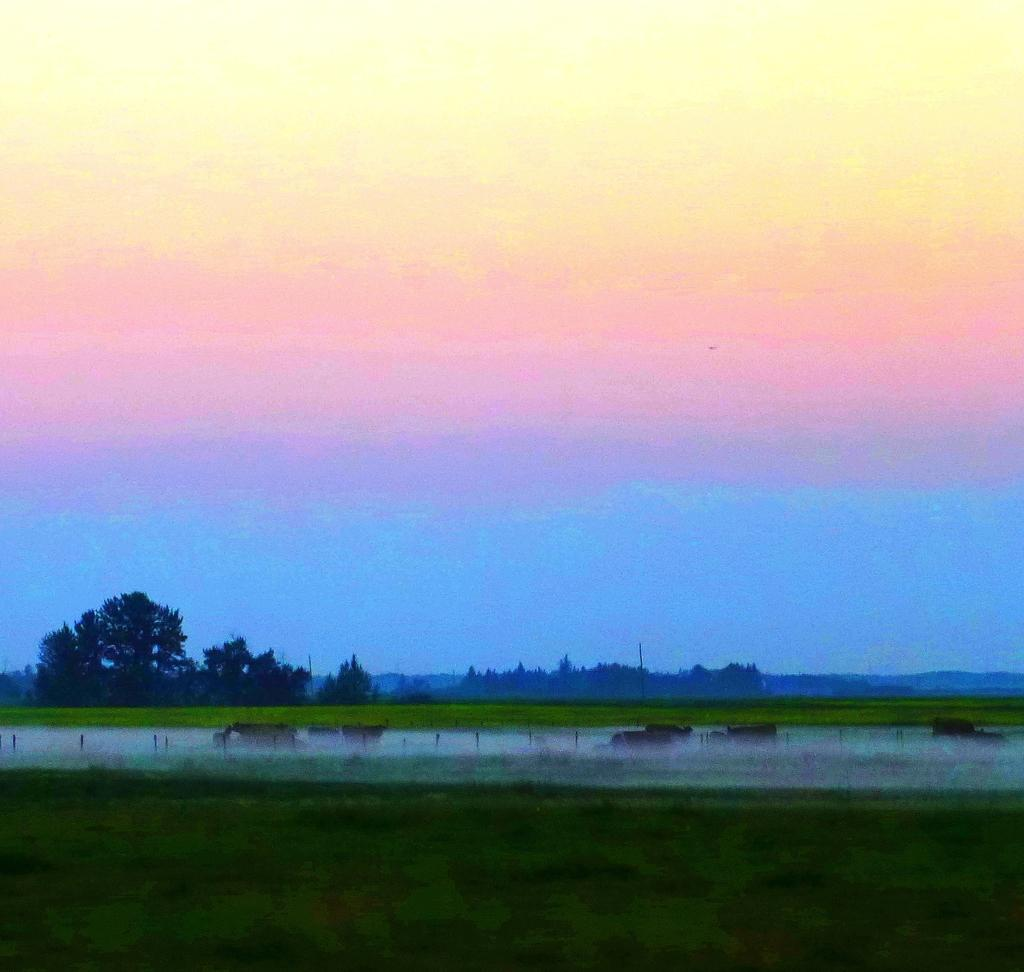What is the primary element visible in the image? There is water in the image. What can be seen near the water? The ground has greenery beside the water. What is visible in the background of the image? There are trees in the background of the image. What type of silver object can be seen in the image? There is no silver object present in the image. What emotion is being displayed by the trees in the image? The trees in the image are not capable of displaying emotions, as they are inanimate objects. 